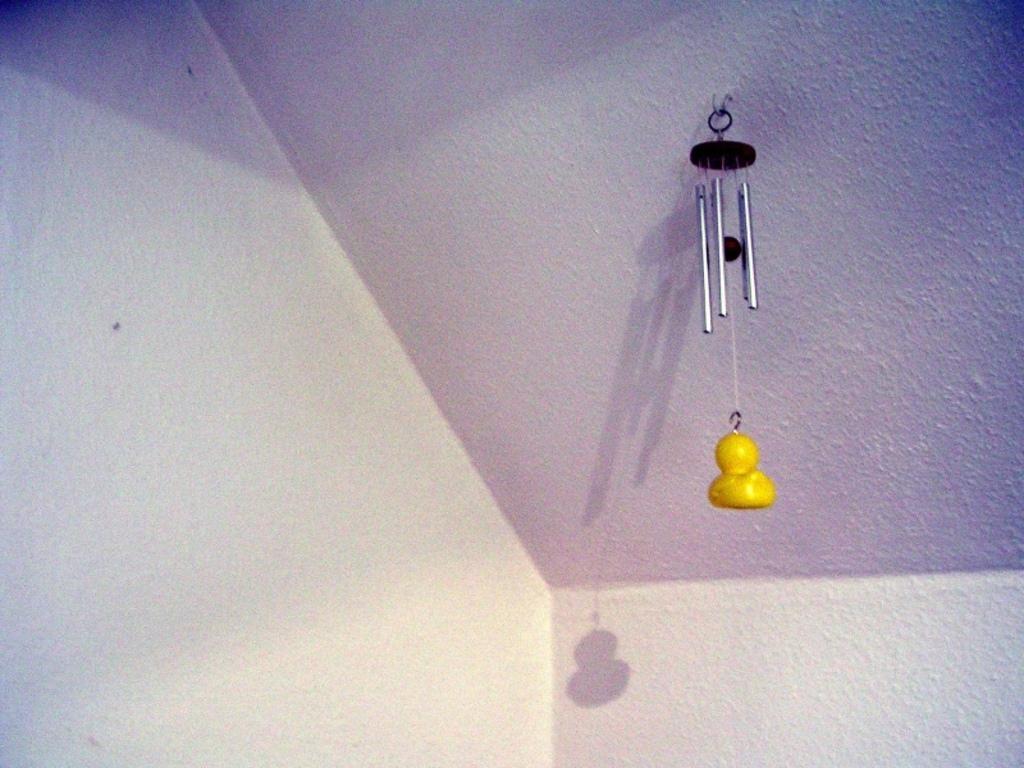Could you give a brief overview of what you see in this image? In this image I can see a yellow colour thing and few pipes on ceiling. I can also see shadows in background. 